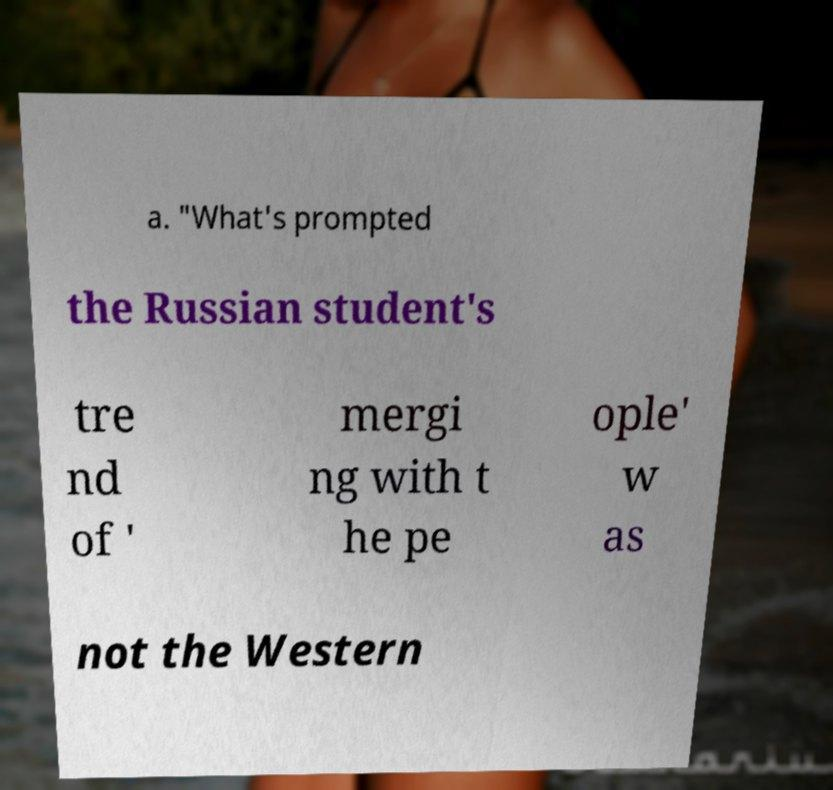For documentation purposes, I need the text within this image transcribed. Could you provide that? a. "What's prompted the Russian student's tre nd of ' mergi ng with t he pe ople' w as not the Western 